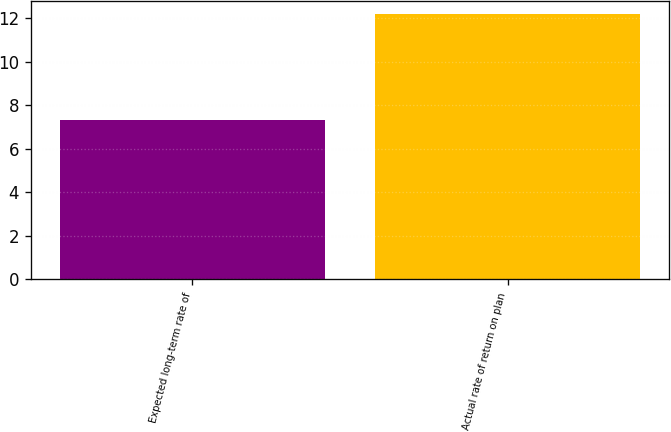Convert chart. <chart><loc_0><loc_0><loc_500><loc_500><bar_chart><fcel>Expected long-term rate of<fcel>Actual rate of return on plan<nl><fcel>7.32<fcel>12.2<nl></chart> 